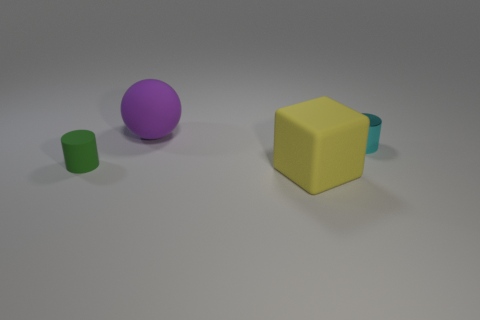There is a small green object that is made of the same material as the big purple thing; what shape is it?
Offer a terse response. Cylinder. Is the number of small cyan cylinders that are in front of the yellow block greater than the number of blocks?
Keep it short and to the point. No. How many other objects are there of the same color as the cube?
Ensure brevity in your answer.  0. Are there more tiny cyan cylinders than small blue spheres?
Offer a very short reply. Yes. What material is the yellow object?
Keep it short and to the point. Rubber. There is a thing that is behind the cyan metallic cylinder; is its size the same as the yellow matte object?
Your response must be concise. Yes. What size is the cylinder left of the cyan cylinder?
Give a very brief answer. Small. Is there any other thing that is the same material as the cyan cylinder?
Offer a terse response. No. How many tiny cyan matte blocks are there?
Offer a very short reply. 0. Do the large matte sphere and the large cube have the same color?
Offer a very short reply. No. 